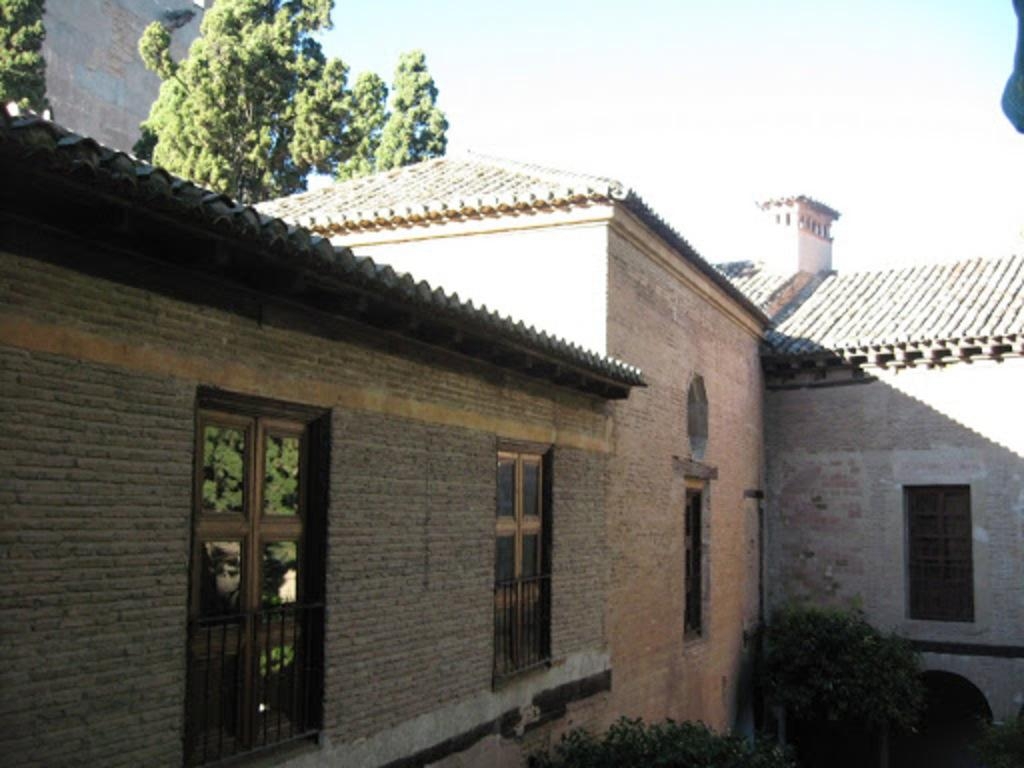What type of structure is present in the image? There is a house in the image. What feature of the house is mentioned in the facts? The house has windows. What other elements can be seen in the image? There are plants and trees in the background of the image. What can be seen in the distance behind the house? The sky is visible in the background of the image. What type of hole can be seen in the image? There is no hole present in the image. What country is the house located in? The facts provided do not give any information about the country where the house is located. 